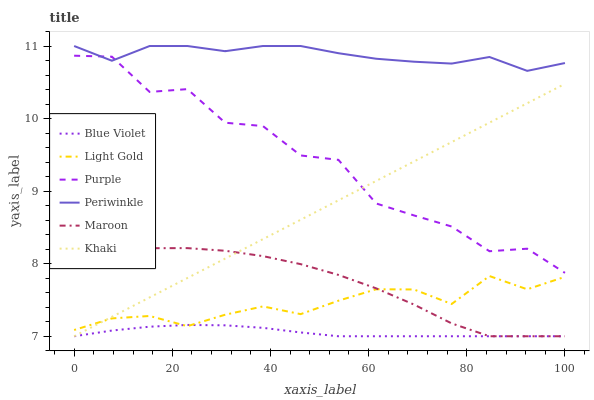Does Blue Violet have the minimum area under the curve?
Answer yes or no. Yes. Does Periwinkle have the maximum area under the curve?
Answer yes or no. Yes. Does Purple have the minimum area under the curve?
Answer yes or no. No. Does Purple have the maximum area under the curve?
Answer yes or no. No. Is Khaki the smoothest?
Answer yes or no. Yes. Is Purple the roughest?
Answer yes or no. Yes. Is Maroon the smoothest?
Answer yes or no. No. Is Maroon the roughest?
Answer yes or no. No. Does Purple have the lowest value?
Answer yes or no. No. Does Purple have the highest value?
Answer yes or no. No. Is Maroon less than Purple?
Answer yes or no. Yes. Is Periwinkle greater than Maroon?
Answer yes or no. Yes. Does Maroon intersect Purple?
Answer yes or no. No. 